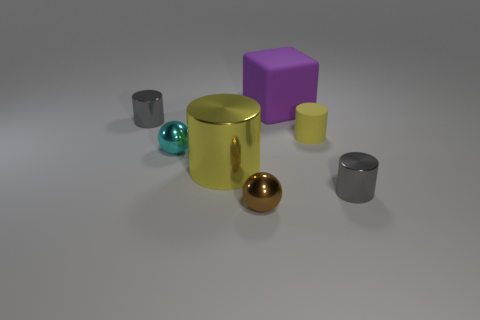Subtract all blue cylinders. Subtract all green spheres. How many cylinders are left? 4 Add 1 small metallic cylinders. How many objects exist? 8 Subtract all balls. How many objects are left? 5 Subtract all cyan metallic objects. Subtract all big rubber blocks. How many objects are left? 5 Add 1 brown spheres. How many brown spheres are left? 2 Add 1 large yellow metallic objects. How many large yellow metallic objects exist? 2 Subtract 0 blue cylinders. How many objects are left? 7 